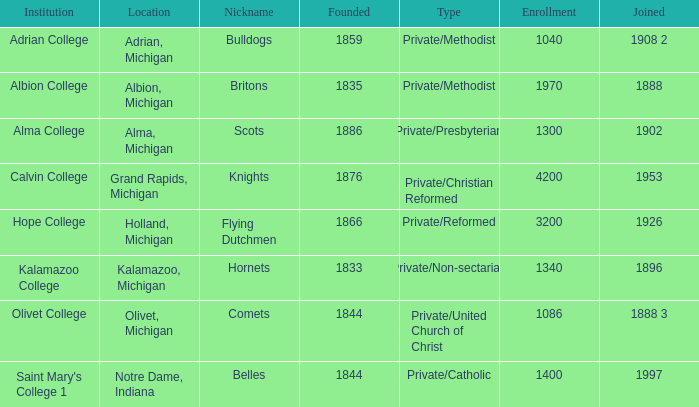Among attractive features, which is the most plausible to be formed? 1844.0. 